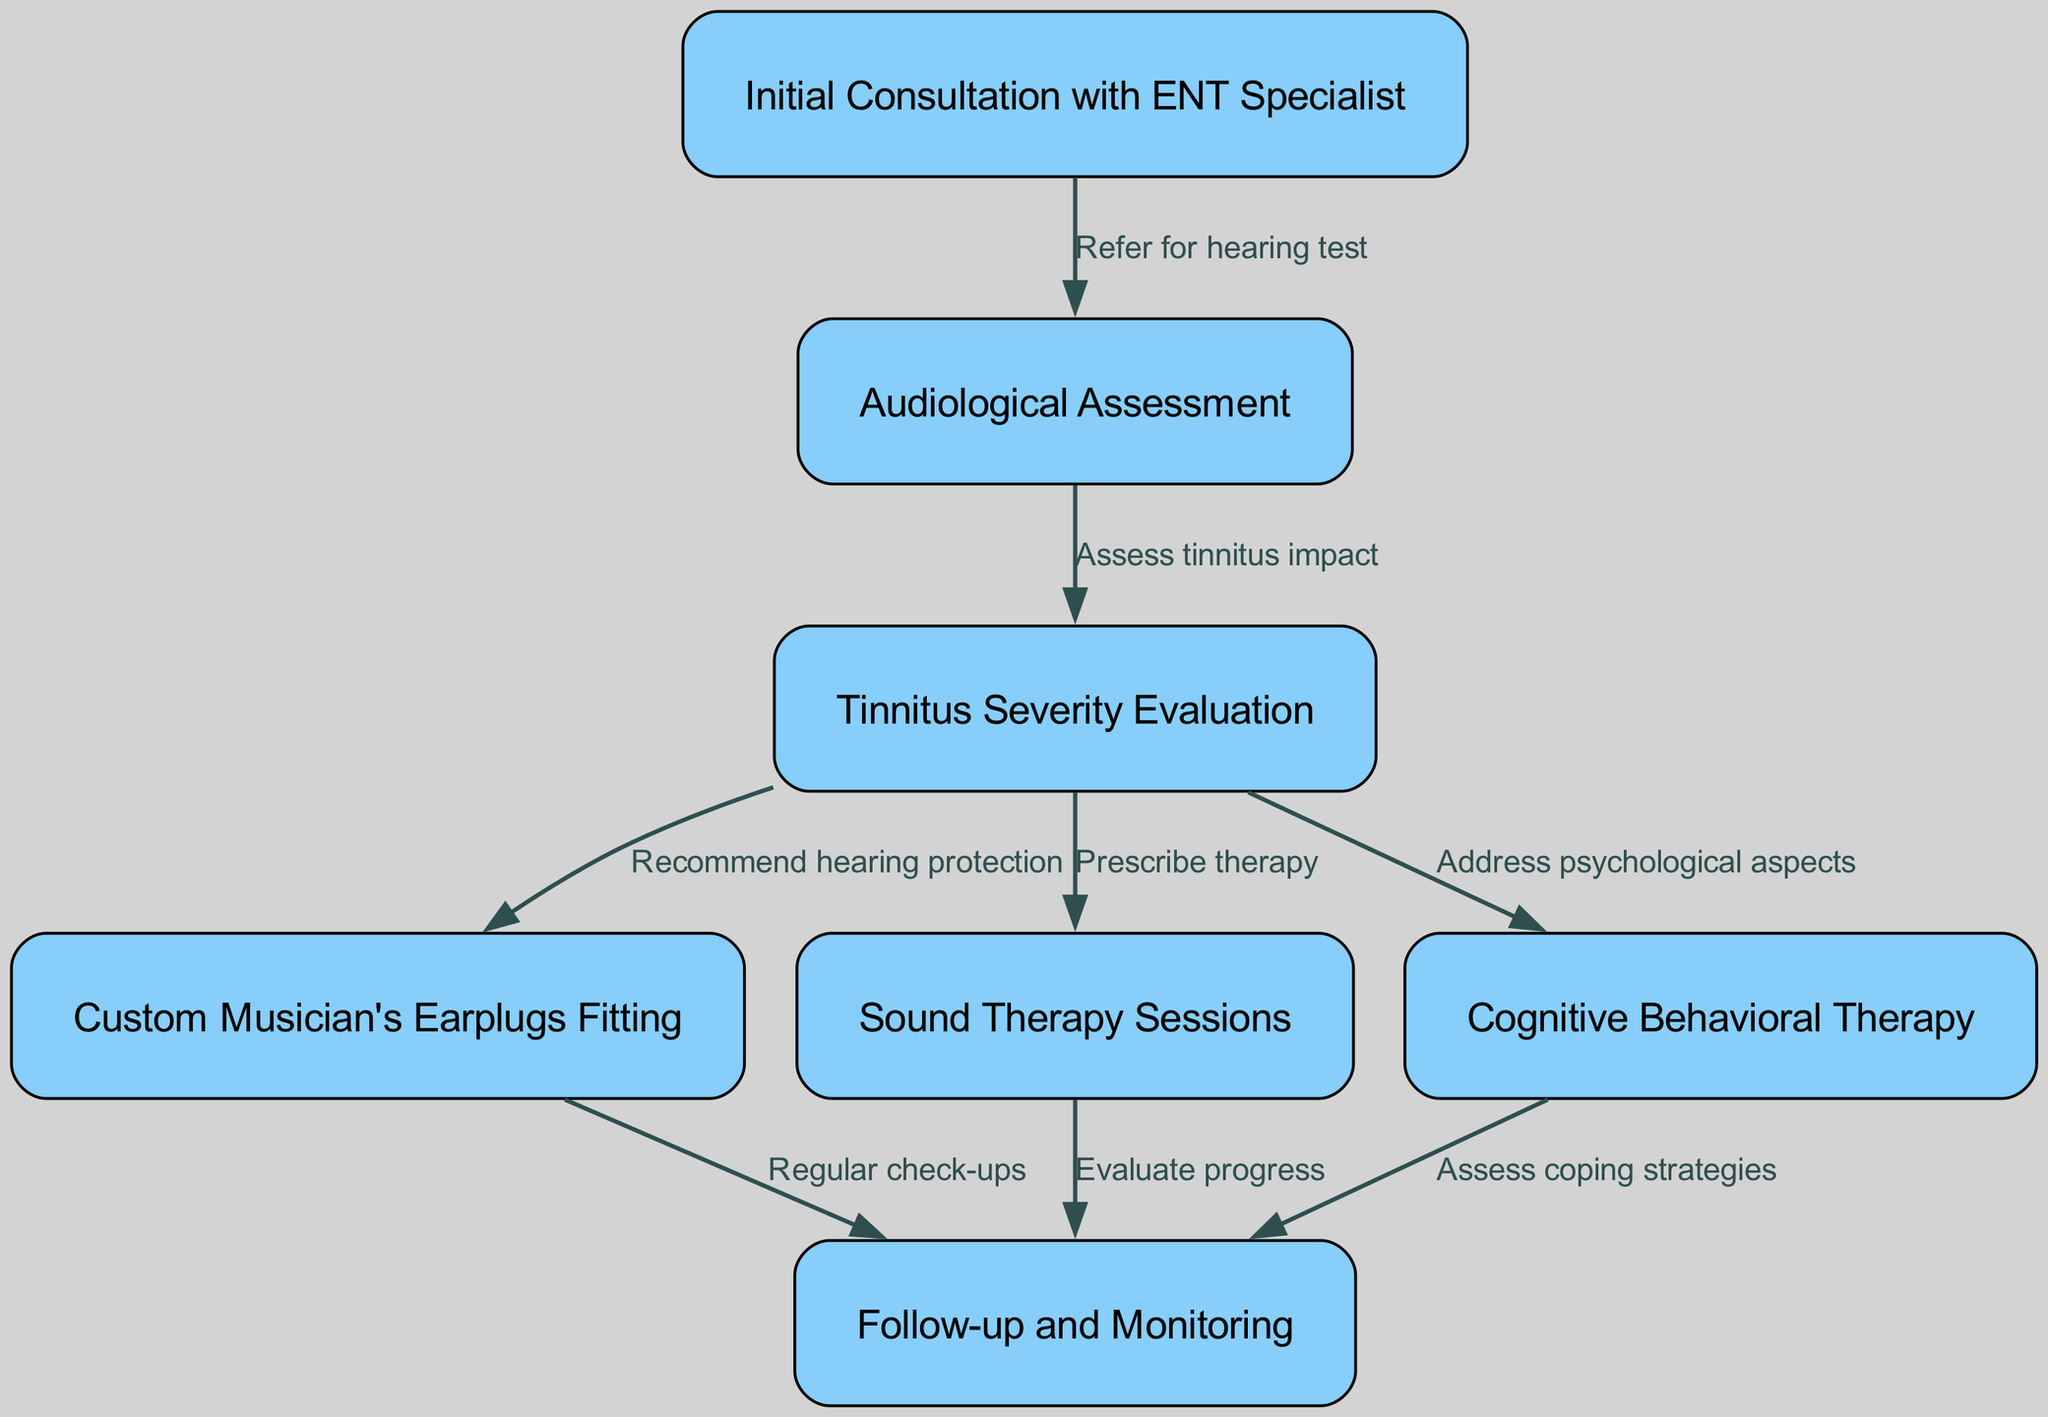What is the first step in the tinnitus management pathway? The diagram starts with the node labeled "Initial Consultation with ENT Specialist," which is the first step in the pathway.
Answer: Initial Consultation with ENT Specialist How many nodes are present in this diagram? The diagram contains 7 nodes, each representing a step in the patient journey for tinnitus management.
Answer: 7 What is the relationship between "Audiological Assessment" and "Tinnitus Severity Evaluation"? "Audiological Assessment" leads to "Tinnitus Severity Evaluation," indicating that the assessment is necessary to evaluate the severity of tinnitus.
Answer: Assess tinnitus impact Which step follows "Custom Musician's Earplugs Fitting"? The graph shows that after "Custom Musician's Earplugs Fitting," the next step is "Follow-up and Monitoring."
Answer: Follow-up and Monitoring What type of therapy is prescribed after evaluating tinnitus severity? According to the diagram, the therapy prescribed after evaluating tinnitus severity is "Sound Therapy Sessions."
Answer: Sound Therapy Sessions What are the main psychological aspects addressed in the pathway? The pathway includes "Cognitive Behavioral Therapy" to address the psychological aspects related to tinnitus management.
Answer: Cognitive Behavioral Therapy What is the final step in the clinical pathway? The diagram indicates that the final step is "Follow-up and Monitoring," where progress and coping strategies are assessed.
Answer: Follow-up and Monitoring How many therapies are prescribed after the tinnitus severity evaluation? The diagram shows three possible therapies after the tinnitus severity evaluation, namely, "Custom Musician's Earplugs Fitting," "Sound Therapy Sessions," and "Cognitive Behavioral Therapy."
Answer: 3 